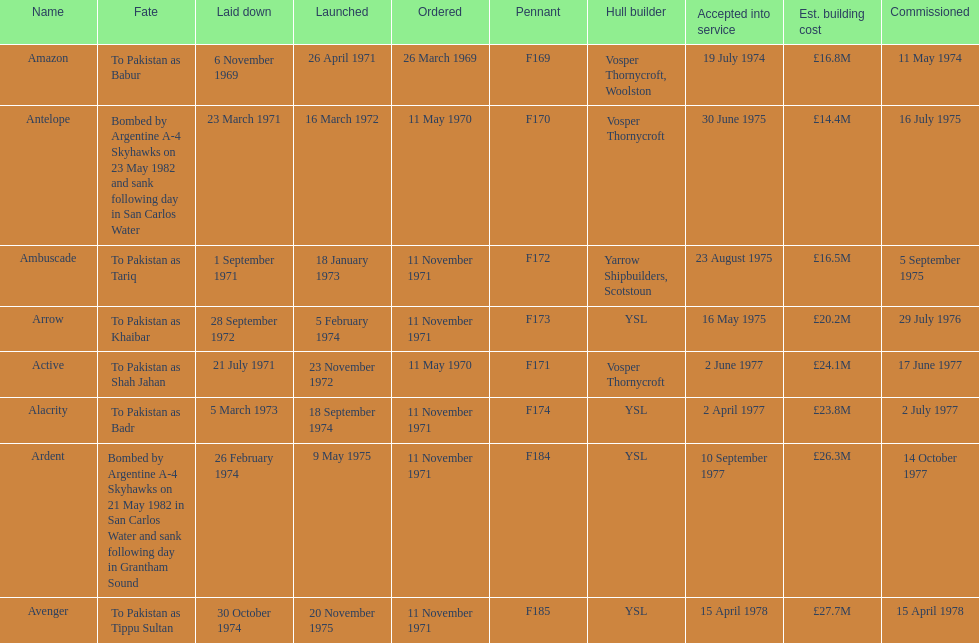The arrow was ordered on november 11, 1971. what was the previous ship? Ambuscade. 